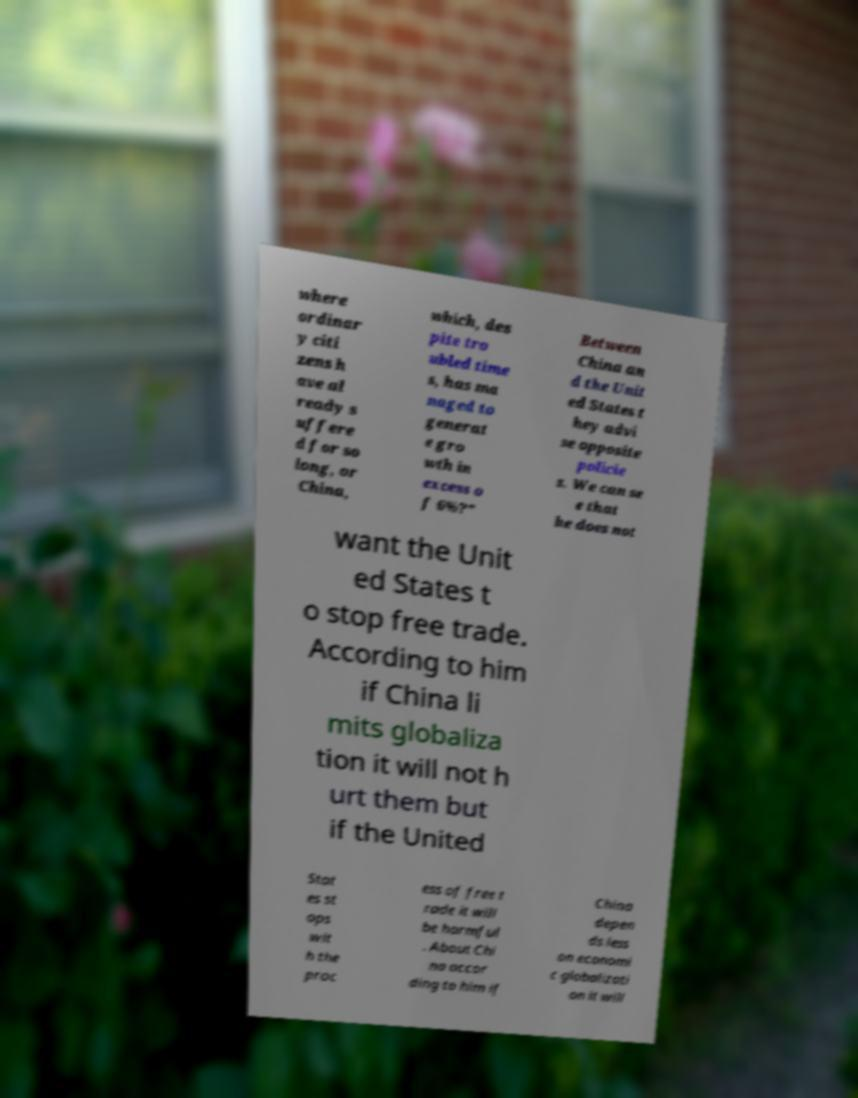What messages or text are displayed in this image? I need them in a readable, typed format. where ordinar y citi zens h ave al ready s uffere d for so long, or China, which, des pite tro ubled time s, has ma naged to generat e gro wth in excess o f 6%?" Between China an d the Unit ed States t hey advi se opposite policie s. We can se e that he does not want the Unit ed States t o stop free trade. According to him if China li mits globaliza tion it will not h urt them but if the United Stat es st ops wit h the proc ess of free t rade it will be harmful . About Chi na accor ding to him if China depen ds less on economi c globalizati on it will 